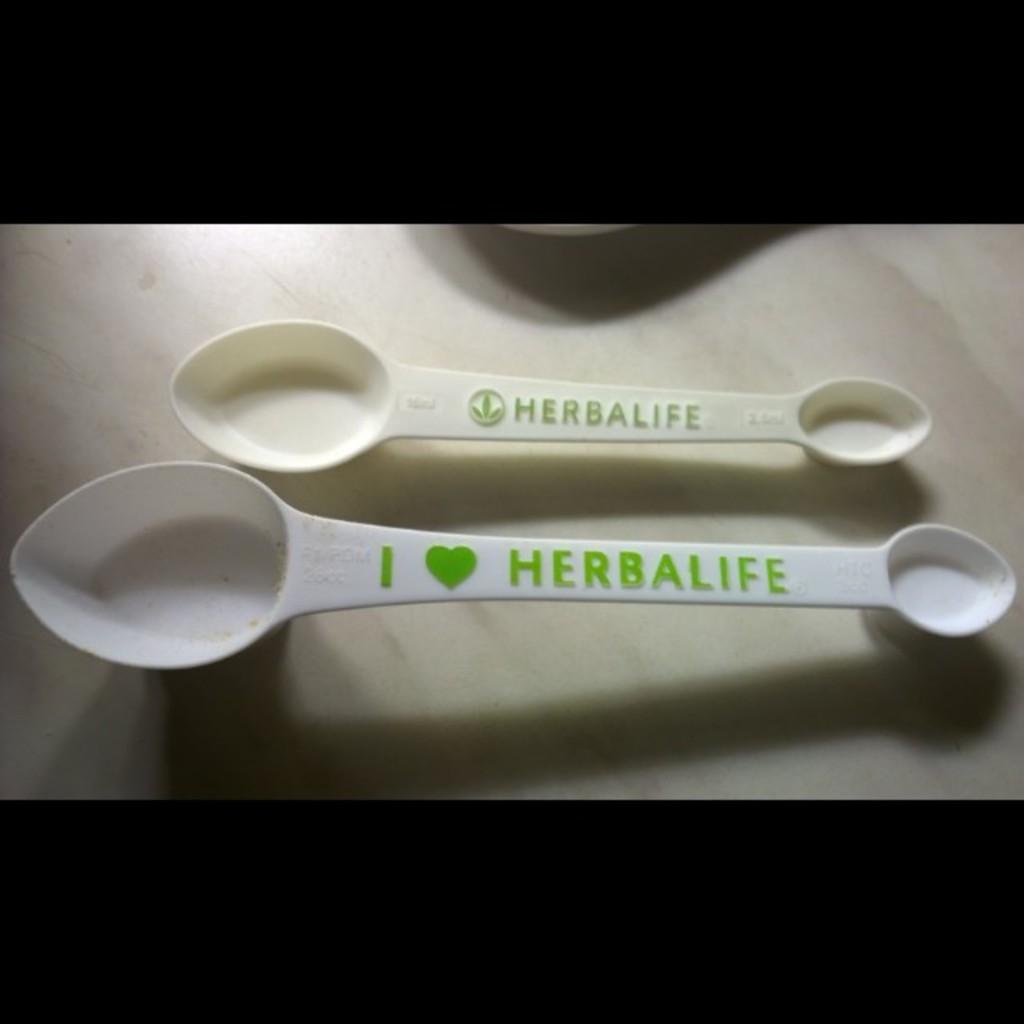What is located in the center of the image? There is a table in the center of the image. What object is placed on the table? There is a spoon on the table. What is written on the spoon? The spoon has "Herbalife" written on it. Can you see any celery on the table in the image? There is no celery present on the table in the image. Is the person's grandfather sitting at the table in the image? There is no person or grandfather mentioned or visible in the image. What type of vacation destination is shown in the image? There is no vacation destination shown in the image; it features a table with a spoon on it. 